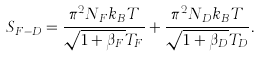Convert formula to latex. <formula><loc_0><loc_0><loc_500><loc_500>S _ { F - D } = \frac { \pi ^ { 2 } N _ { F } k _ { B } T } { \sqrt { 1 + \beta _ { F } } T _ { F } } + \frac { \pi ^ { 2 } N _ { D } k _ { B } T } { \sqrt { 1 + \beta _ { D } } T _ { D } } .</formula> 